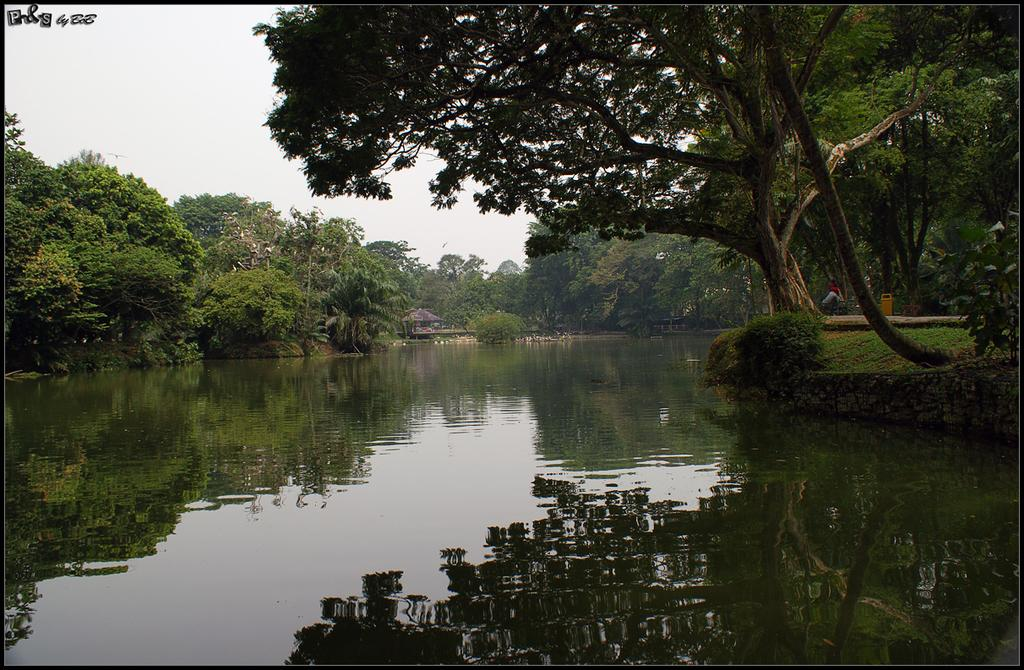What is the primary element visible in the image? There is water in the image. What type of vegetation is present on the sides of the image? There are trees on the sides of the image. What can be seen in the background of the image? There is sky and a shed visible in the background of the image. Is there any text or writing in the image? Yes, something is written in the left top corner of the image. What type of skirt is the carpenter wearing in the image? There is no carpenter or skirt present in the image. How many pockets are visible on the carpenter's clothing in the image? There is no carpenter or clothing with pockets present in the image. 